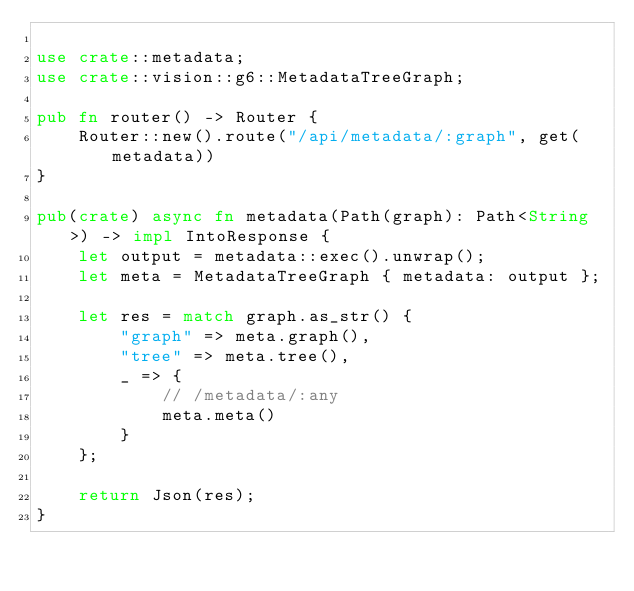Convert code to text. <code><loc_0><loc_0><loc_500><loc_500><_Rust_>
use crate::metadata;
use crate::vision::g6::MetadataTreeGraph;

pub fn router() -> Router {
    Router::new().route("/api/metadata/:graph", get(metadata))
}

pub(crate) async fn metadata(Path(graph): Path<String>) -> impl IntoResponse {
    let output = metadata::exec().unwrap();
    let meta = MetadataTreeGraph { metadata: output };

    let res = match graph.as_str() {
        "graph" => meta.graph(),
        "tree" => meta.tree(),
        _ => {
            // /metadata/:any
            meta.meta()
        }
    };

    return Json(res);
}
</code> 